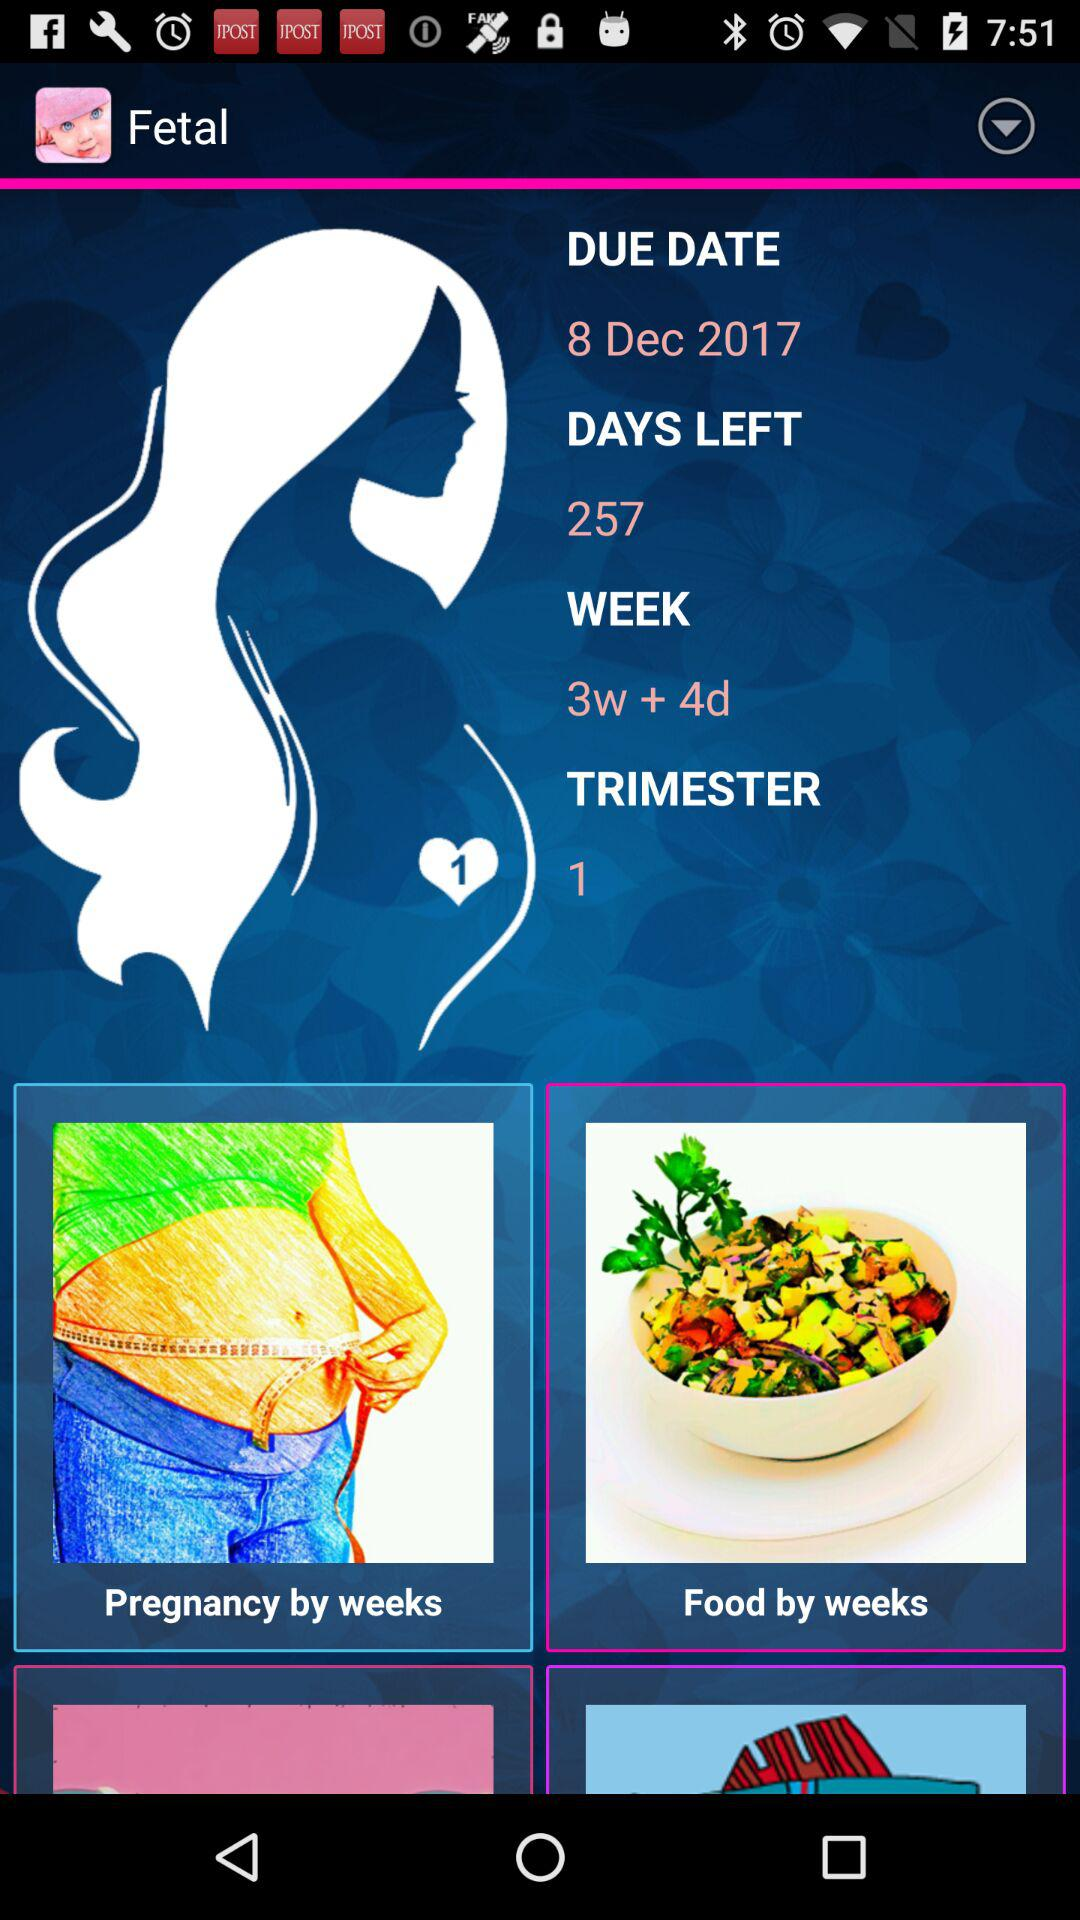How many days are left? There are 257 days left. 